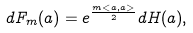<formula> <loc_0><loc_0><loc_500><loc_500>d F _ { m } ( a ) = e ^ { \frac { m < a , a > } { 2 } } d H ( a ) ,</formula> 